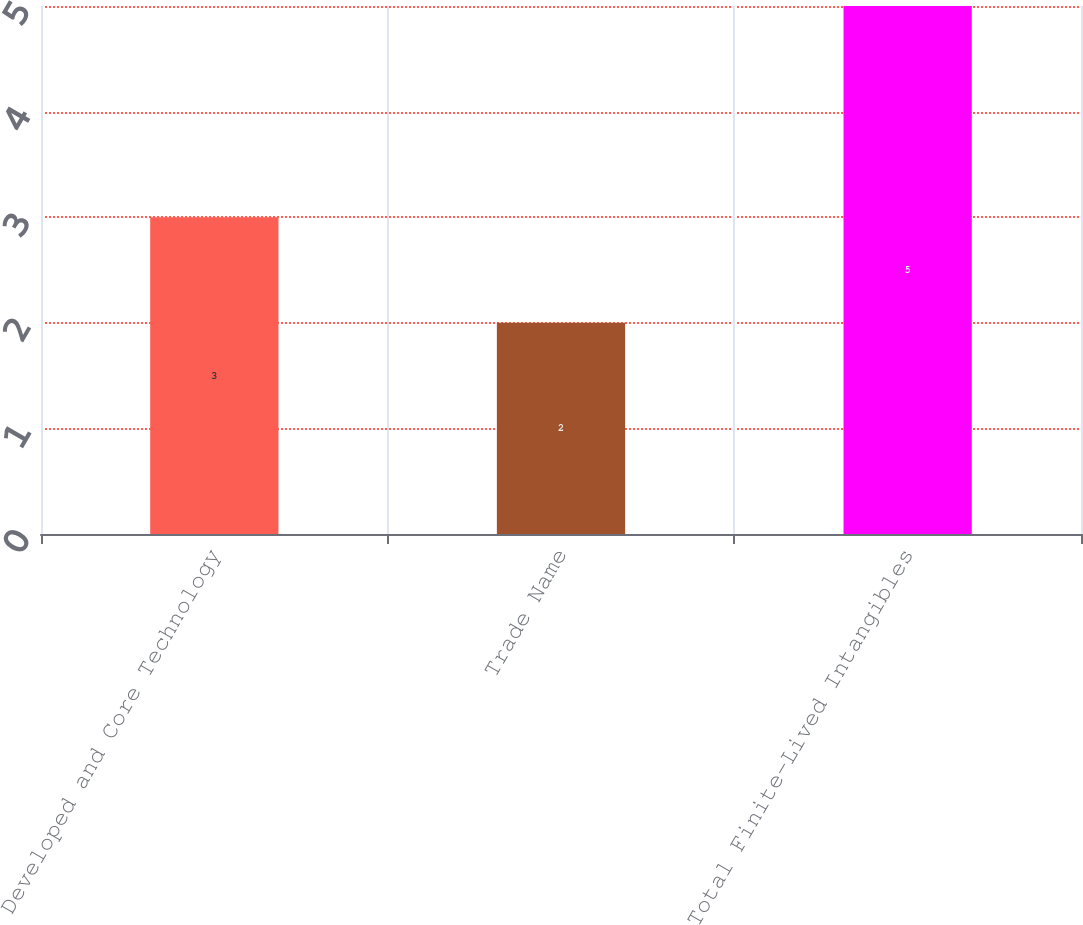Convert chart to OTSL. <chart><loc_0><loc_0><loc_500><loc_500><bar_chart><fcel>Developed and Core Technology<fcel>Trade Name<fcel>Total Finite-Lived Intangibles<nl><fcel>3<fcel>2<fcel>5<nl></chart> 